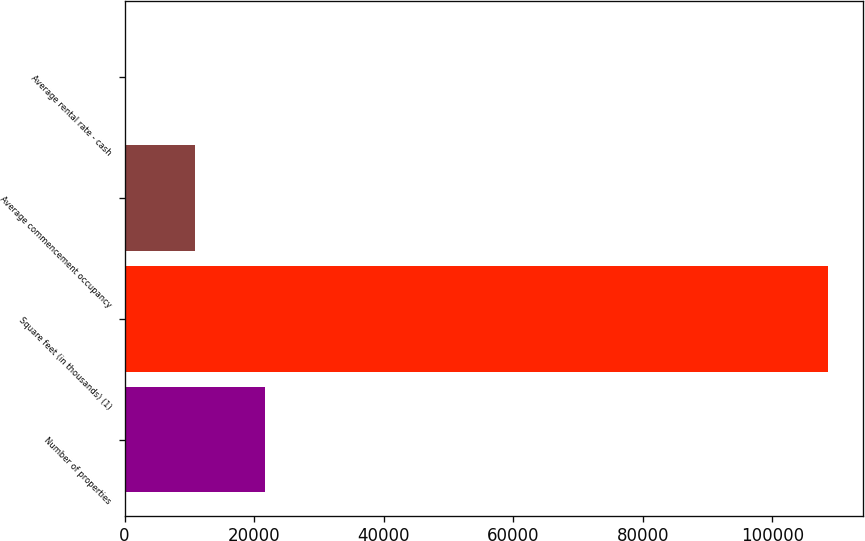Convert chart to OTSL. <chart><loc_0><loc_0><loc_500><loc_500><bar_chart><fcel>Number of properties<fcel>Square feet (in thousands) (1)<fcel>Average commencement occupancy<fcel>Average rental rate - cash<nl><fcel>21724.6<fcel>108604<fcel>10864.7<fcel>4.78<nl></chart> 